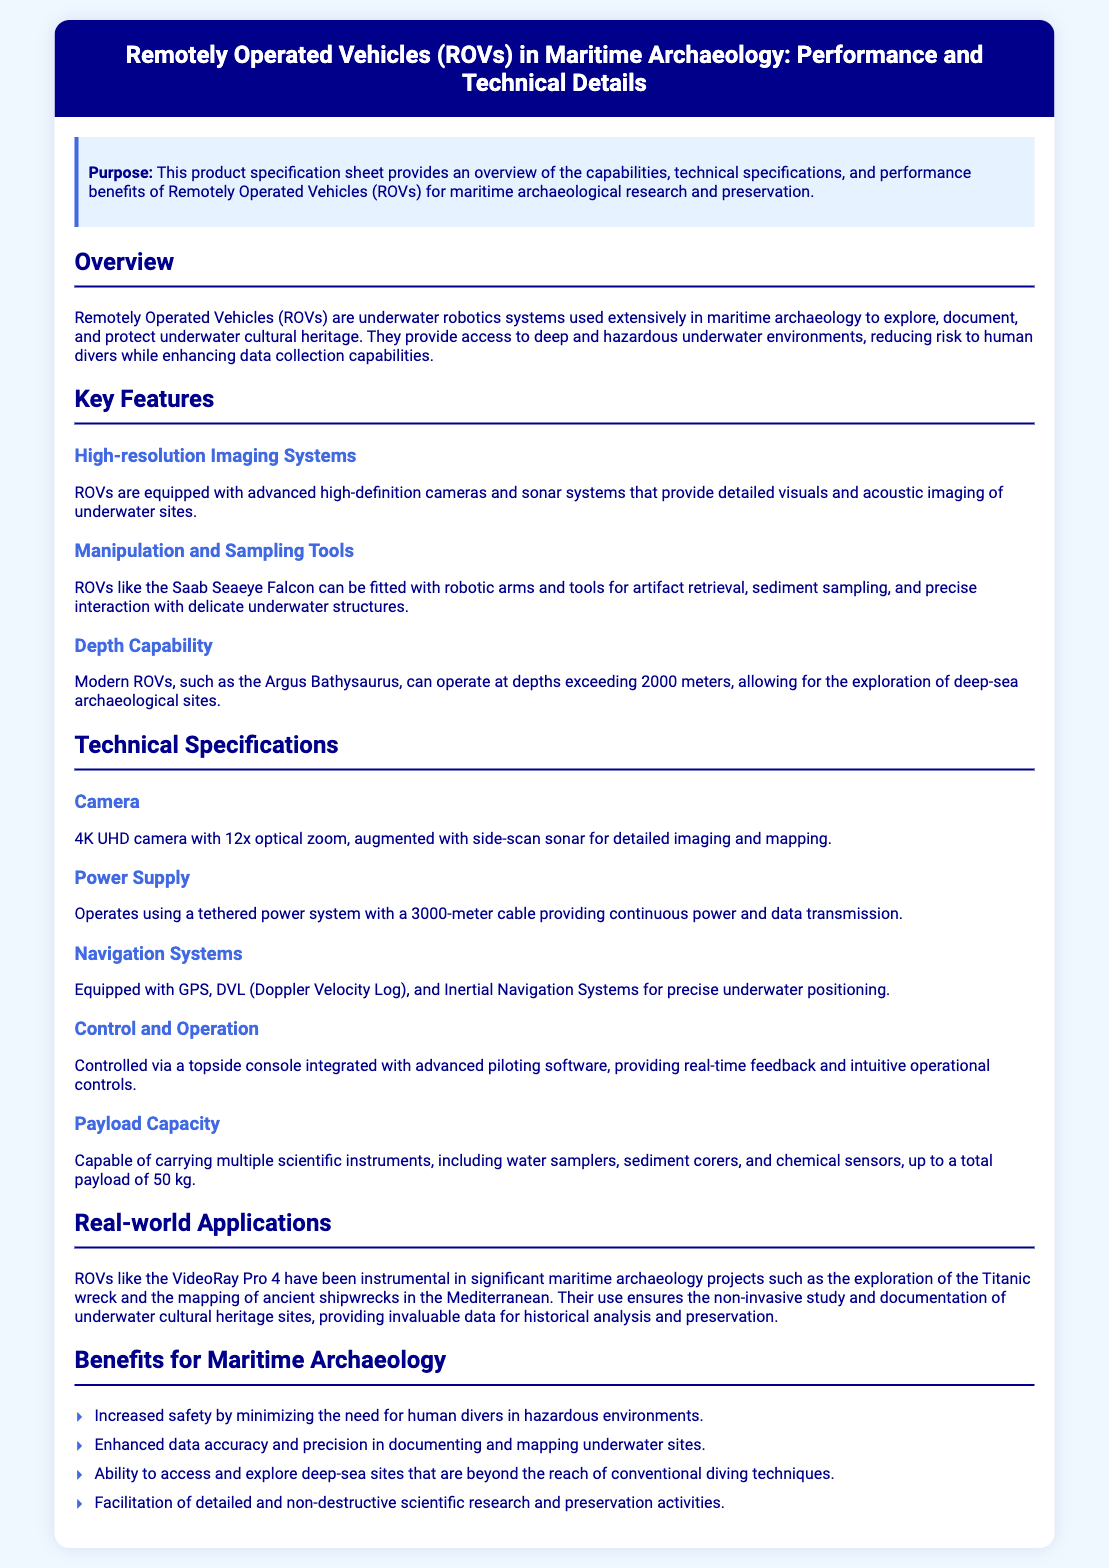What is the purpose of this product specification sheet? The specification sheet provides an overview of the capabilities, technical specifications, and performance benefits of ROVs for maritime archaeological research and preservation.
Answer: Overview of the capabilities, technical specifications, and performance benefits What is the depth capability of modern ROVs? Modern ROVs, such as the Argus Bathysaurus, can operate at depths exceeding 2000 meters.
Answer: Exceeding 2000 meters What type of camera do ROVs use? ROVs are equipped with a 4K UHD camera with 12x optical zoom, augmented with side-scan sonar.
Answer: 4K UHD camera with 12x optical zoom What is the payload capacity of the ROVs? The ROVs can carry a total payload of 50 kg.
Answer: 50 kg What are the real-world applications of ROVs mentioned? ROVs like the VideoRay Pro 4 have been used in exploring the Titanic wreck and mapping ancient shipwrecks in the Mediterranean.
Answer: Exploration of the Titanic wreck and mapping of ancient shipwrecks Why are ROVs beneficial for maritime archaeology? ROVs increase safety, enhance data accuracy, allow access to deep-sea sites, and facilitate non-destructive research.
Answer: Increased safety, enhanced data accuracy, access to deep-sea sites, non-destructive research What is the function of the manipulation and sampling tools on ROVs? The tools allow for artifact retrieval, sediment sampling, and precise interaction with delicate underwater structures.
Answer: Artifact retrieval, sediment sampling, precise interaction How is the power supplied to the ROVs? The ROVs operate using a tethered power system with a 3000-meter cable.
Answer: Tethered power system with a 3000-meter cable What navigation systems are included in ROVs? ROVs are equipped with GPS, DVL, and Inertial Navigation Systems.
Answer: GPS, DVL, Inertial Navigation Systems 